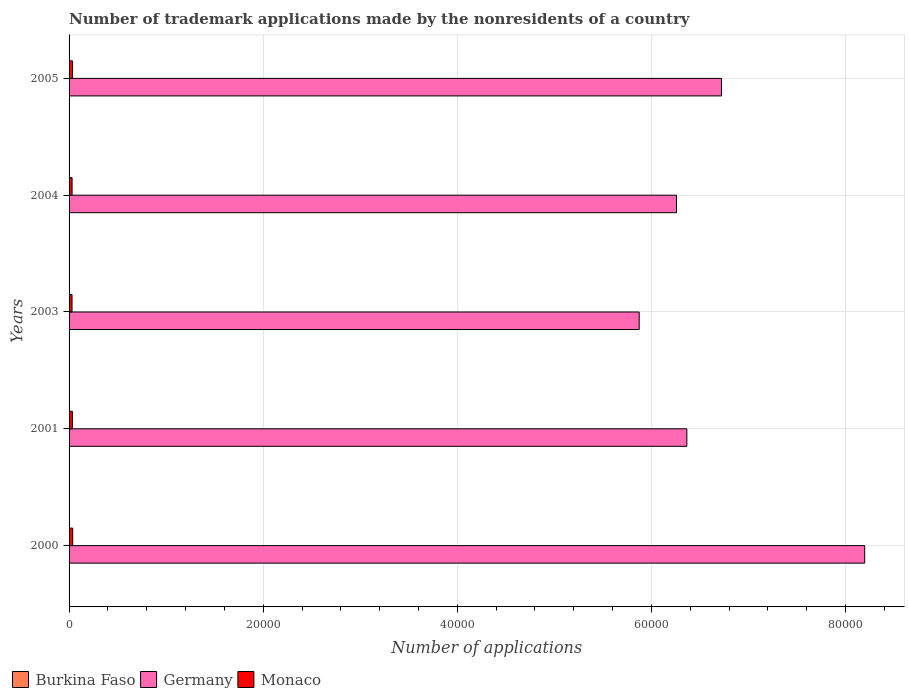How many groups of bars are there?
Your answer should be compact. 5. How many bars are there on the 2nd tick from the bottom?
Ensure brevity in your answer.  3. In how many cases, is the number of bars for a given year not equal to the number of legend labels?
Give a very brief answer. 0. Across all years, what is the maximum number of trademark applications made by the nonresidents in Germany?
Your answer should be compact. 8.20e+04. Across all years, what is the minimum number of trademark applications made by the nonresidents in Monaco?
Your response must be concise. 305. In which year was the number of trademark applications made by the nonresidents in Germany minimum?
Make the answer very short. 2003. What is the total number of trademark applications made by the nonresidents in Germany in the graph?
Your response must be concise. 3.34e+05. What is the difference between the number of trademark applications made by the nonresidents in Germany in 2000 and that in 2003?
Offer a very short reply. 2.32e+04. What is the difference between the number of trademark applications made by the nonresidents in Germany in 2005 and the number of trademark applications made by the nonresidents in Monaco in 2003?
Offer a very short reply. 6.69e+04. What is the average number of trademark applications made by the nonresidents in Germany per year?
Provide a short and direct response. 6.68e+04. In the year 2004, what is the difference between the number of trademark applications made by the nonresidents in Burkina Faso and number of trademark applications made by the nonresidents in Germany?
Give a very brief answer. -6.25e+04. In how many years, is the number of trademark applications made by the nonresidents in Germany greater than 56000 ?
Provide a succinct answer. 5. What is the ratio of the number of trademark applications made by the nonresidents in Germany in 2001 to that in 2005?
Provide a succinct answer. 0.95. Is the number of trademark applications made by the nonresidents in Germany in 2000 less than that in 2005?
Your answer should be compact. No. What is the difference between the highest and the lowest number of trademark applications made by the nonresidents in Germany?
Keep it short and to the point. 2.32e+04. In how many years, is the number of trademark applications made by the nonresidents in Germany greater than the average number of trademark applications made by the nonresidents in Germany taken over all years?
Your answer should be very brief. 2. Is the sum of the number of trademark applications made by the nonresidents in Monaco in 2001 and 2003 greater than the maximum number of trademark applications made by the nonresidents in Burkina Faso across all years?
Offer a very short reply. Yes. What does the 1st bar from the bottom in 2004 represents?
Offer a terse response. Burkina Faso. Is it the case that in every year, the sum of the number of trademark applications made by the nonresidents in Germany and number of trademark applications made by the nonresidents in Monaco is greater than the number of trademark applications made by the nonresidents in Burkina Faso?
Your answer should be compact. Yes. Are all the bars in the graph horizontal?
Your answer should be very brief. Yes. What is the difference between two consecutive major ticks on the X-axis?
Offer a terse response. 2.00e+04. Are the values on the major ticks of X-axis written in scientific E-notation?
Offer a very short reply. No. Does the graph contain grids?
Ensure brevity in your answer.  Yes. Where does the legend appear in the graph?
Offer a terse response. Bottom left. How many legend labels are there?
Ensure brevity in your answer.  3. What is the title of the graph?
Offer a very short reply. Number of trademark applications made by the nonresidents of a country. What is the label or title of the X-axis?
Provide a short and direct response. Number of applications. What is the Number of applications of Germany in 2000?
Keep it short and to the point. 8.20e+04. What is the Number of applications in Monaco in 2000?
Your answer should be very brief. 374. What is the Number of applications in Germany in 2001?
Keep it short and to the point. 6.36e+04. What is the Number of applications in Monaco in 2001?
Your answer should be compact. 341. What is the Number of applications of Burkina Faso in 2003?
Give a very brief answer. 35. What is the Number of applications of Germany in 2003?
Provide a succinct answer. 5.87e+04. What is the Number of applications in Monaco in 2003?
Ensure brevity in your answer.  305. What is the Number of applications of Burkina Faso in 2004?
Make the answer very short. 42. What is the Number of applications in Germany in 2004?
Give a very brief answer. 6.26e+04. What is the Number of applications in Monaco in 2004?
Give a very brief answer. 310. What is the Number of applications in Germany in 2005?
Provide a succinct answer. 6.72e+04. What is the Number of applications of Monaco in 2005?
Your answer should be compact. 359. Across all years, what is the maximum Number of applications of Burkina Faso?
Your response must be concise. 42. Across all years, what is the maximum Number of applications in Germany?
Keep it short and to the point. 8.20e+04. Across all years, what is the maximum Number of applications of Monaco?
Provide a succinct answer. 374. Across all years, what is the minimum Number of applications of Burkina Faso?
Make the answer very short. 5. Across all years, what is the minimum Number of applications in Germany?
Provide a short and direct response. 5.87e+04. Across all years, what is the minimum Number of applications in Monaco?
Provide a short and direct response. 305. What is the total Number of applications of Burkina Faso in the graph?
Your response must be concise. 127. What is the total Number of applications of Germany in the graph?
Keep it short and to the point. 3.34e+05. What is the total Number of applications in Monaco in the graph?
Provide a short and direct response. 1689. What is the difference between the Number of applications in Germany in 2000 and that in 2001?
Provide a succinct answer. 1.83e+04. What is the difference between the Number of applications of Monaco in 2000 and that in 2001?
Your answer should be compact. 33. What is the difference between the Number of applications in Germany in 2000 and that in 2003?
Provide a short and direct response. 2.32e+04. What is the difference between the Number of applications in Burkina Faso in 2000 and that in 2004?
Provide a succinct answer. -37. What is the difference between the Number of applications in Germany in 2000 and that in 2004?
Your answer should be very brief. 1.94e+04. What is the difference between the Number of applications of Burkina Faso in 2000 and that in 2005?
Provide a succinct answer. -25. What is the difference between the Number of applications in Germany in 2000 and that in 2005?
Offer a terse response. 1.48e+04. What is the difference between the Number of applications of Burkina Faso in 2001 and that in 2003?
Offer a terse response. -20. What is the difference between the Number of applications in Germany in 2001 and that in 2003?
Your response must be concise. 4910. What is the difference between the Number of applications of Burkina Faso in 2001 and that in 2004?
Provide a short and direct response. -27. What is the difference between the Number of applications in Germany in 2001 and that in 2004?
Provide a succinct answer. 1065. What is the difference between the Number of applications in Monaco in 2001 and that in 2004?
Provide a short and direct response. 31. What is the difference between the Number of applications in Germany in 2001 and that in 2005?
Your response must be concise. -3567. What is the difference between the Number of applications of Monaco in 2001 and that in 2005?
Offer a very short reply. -18. What is the difference between the Number of applications of Burkina Faso in 2003 and that in 2004?
Keep it short and to the point. -7. What is the difference between the Number of applications in Germany in 2003 and that in 2004?
Offer a terse response. -3845. What is the difference between the Number of applications in Monaco in 2003 and that in 2004?
Provide a short and direct response. -5. What is the difference between the Number of applications in Germany in 2003 and that in 2005?
Ensure brevity in your answer.  -8477. What is the difference between the Number of applications in Monaco in 2003 and that in 2005?
Your answer should be very brief. -54. What is the difference between the Number of applications of Burkina Faso in 2004 and that in 2005?
Ensure brevity in your answer.  12. What is the difference between the Number of applications of Germany in 2004 and that in 2005?
Provide a succinct answer. -4632. What is the difference between the Number of applications of Monaco in 2004 and that in 2005?
Your answer should be compact. -49. What is the difference between the Number of applications of Burkina Faso in 2000 and the Number of applications of Germany in 2001?
Make the answer very short. -6.36e+04. What is the difference between the Number of applications in Burkina Faso in 2000 and the Number of applications in Monaco in 2001?
Keep it short and to the point. -336. What is the difference between the Number of applications in Germany in 2000 and the Number of applications in Monaco in 2001?
Provide a short and direct response. 8.16e+04. What is the difference between the Number of applications of Burkina Faso in 2000 and the Number of applications of Germany in 2003?
Provide a succinct answer. -5.87e+04. What is the difference between the Number of applications in Burkina Faso in 2000 and the Number of applications in Monaco in 2003?
Your answer should be very brief. -300. What is the difference between the Number of applications of Germany in 2000 and the Number of applications of Monaco in 2003?
Give a very brief answer. 8.17e+04. What is the difference between the Number of applications in Burkina Faso in 2000 and the Number of applications in Germany in 2004?
Make the answer very short. -6.26e+04. What is the difference between the Number of applications of Burkina Faso in 2000 and the Number of applications of Monaco in 2004?
Keep it short and to the point. -305. What is the difference between the Number of applications in Germany in 2000 and the Number of applications in Monaco in 2004?
Offer a terse response. 8.17e+04. What is the difference between the Number of applications of Burkina Faso in 2000 and the Number of applications of Germany in 2005?
Ensure brevity in your answer.  -6.72e+04. What is the difference between the Number of applications in Burkina Faso in 2000 and the Number of applications in Monaco in 2005?
Provide a short and direct response. -354. What is the difference between the Number of applications of Germany in 2000 and the Number of applications of Monaco in 2005?
Provide a short and direct response. 8.16e+04. What is the difference between the Number of applications of Burkina Faso in 2001 and the Number of applications of Germany in 2003?
Offer a very short reply. -5.87e+04. What is the difference between the Number of applications of Burkina Faso in 2001 and the Number of applications of Monaco in 2003?
Provide a short and direct response. -290. What is the difference between the Number of applications of Germany in 2001 and the Number of applications of Monaco in 2003?
Your response must be concise. 6.33e+04. What is the difference between the Number of applications of Burkina Faso in 2001 and the Number of applications of Germany in 2004?
Keep it short and to the point. -6.26e+04. What is the difference between the Number of applications of Burkina Faso in 2001 and the Number of applications of Monaco in 2004?
Your response must be concise. -295. What is the difference between the Number of applications in Germany in 2001 and the Number of applications in Monaco in 2004?
Offer a terse response. 6.33e+04. What is the difference between the Number of applications in Burkina Faso in 2001 and the Number of applications in Germany in 2005?
Provide a succinct answer. -6.72e+04. What is the difference between the Number of applications of Burkina Faso in 2001 and the Number of applications of Monaco in 2005?
Offer a very short reply. -344. What is the difference between the Number of applications of Germany in 2001 and the Number of applications of Monaco in 2005?
Offer a very short reply. 6.33e+04. What is the difference between the Number of applications of Burkina Faso in 2003 and the Number of applications of Germany in 2004?
Give a very brief answer. -6.25e+04. What is the difference between the Number of applications in Burkina Faso in 2003 and the Number of applications in Monaco in 2004?
Your response must be concise. -275. What is the difference between the Number of applications in Germany in 2003 and the Number of applications in Monaco in 2004?
Ensure brevity in your answer.  5.84e+04. What is the difference between the Number of applications of Burkina Faso in 2003 and the Number of applications of Germany in 2005?
Your response must be concise. -6.72e+04. What is the difference between the Number of applications in Burkina Faso in 2003 and the Number of applications in Monaco in 2005?
Give a very brief answer. -324. What is the difference between the Number of applications in Germany in 2003 and the Number of applications in Monaco in 2005?
Provide a short and direct response. 5.84e+04. What is the difference between the Number of applications of Burkina Faso in 2004 and the Number of applications of Germany in 2005?
Your response must be concise. -6.72e+04. What is the difference between the Number of applications of Burkina Faso in 2004 and the Number of applications of Monaco in 2005?
Your answer should be compact. -317. What is the difference between the Number of applications in Germany in 2004 and the Number of applications in Monaco in 2005?
Your response must be concise. 6.22e+04. What is the average Number of applications in Burkina Faso per year?
Offer a terse response. 25.4. What is the average Number of applications of Germany per year?
Your response must be concise. 6.68e+04. What is the average Number of applications in Monaco per year?
Provide a succinct answer. 337.8. In the year 2000, what is the difference between the Number of applications of Burkina Faso and Number of applications of Germany?
Ensure brevity in your answer.  -8.20e+04. In the year 2000, what is the difference between the Number of applications of Burkina Faso and Number of applications of Monaco?
Provide a succinct answer. -369. In the year 2000, what is the difference between the Number of applications of Germany and Number of applications of Monaco?
Offer a terse response. 8.16e+04. In the year 2001, what is the difference between the Number of applications in Burkina Faso and Number of applications in Germany?
Ensure brevity in your answer.  -6.36e+04. In the year 2001, what is the difference between the Number of applications in Burkina Faso and Number of applications in Monaco?
Make the answer very short. -326. In the year 2001, what is the difference between the Number of applications of Germany and Number of applications of Monaco?
Your answer should be very brief. 6.33e+04. In the year 2003, what is the difference between the Number of applications of Burkina Faso and Number of applications of Germany?
Offer a terse response. -5.87e+04. In the year 2003, what is the difference between the Number of applications of Burkina Faso and Number of applications of Monaco?
Make the answer very short. -270. In the year 2003, what is the difference between the Number of applications in Germany and Number of applications in Monaco?
Ensure brevity in your answer.  5.84e+04. In the year 2004, what is the difference between the Number of applications in Burkina Faso and Number of applications in Germany?
Give a very brief answer. -6.25e+04. In the year 2004, what is the difference between the Number of applications in Burkina Faso and Number of applications in Monaco?
Provide a succinct answer. -268. In the year 2004, what is the difference between the Number of applications in Germany and Number of applications in Monaco?
Your answer should be compact. 6.23e+04. In the year 2005, what is the difference between the Number of applications in Burkina Faso and Number of applications in Germany?
Ensure brevity in your answer.  -6.72e+04. In the year 2005, what is the difference between the Number of applications in Burkina Faso and Number of applications in Monaco?
Offer a terse response. -329. In the year 2005, what is the difference between the Number of applications in Germany and Number of applications in Monaco?
Provide a short and direct response. 6.69e+04. What is the ratio of the Number of applications of Germany in 2000 to that in 2001?
Offer a very short reply. 1.29. What is the ratio of the Number of applications in Monaco in 2000 to that in 2001?
Keep it short and to the point. 1.1. What is the ratio of the Number of applications in Burkina Faso in 2000 to that in 2003?
Ensure brevity in your answer.  0.14. What is the ratio of the Number of applications of Germany in 2000 to that in 2003?
Ensure brevity in your answer.  1.4. What is the ratio of the Number of applications in Monaco in 2000 to that in 2003?
Ensure brevity in your answer.  1.23. What is the ratio of the Number of applications of Burkina Faso in 2000 to that in 2004?
Provide a short and direct response. 0.12. What is the ratio of the Number of applications of Germany in 2000 to that in 2004?
Keep it short and to the point. 1.31. What is the ratio of the Number of applications of Monaco in 2000 to that in 2004?
Ensure brevity in your answer.  1.21. What is the ratio of the Number of applications of Burkina Faso in 2000 to that in 2005?
Keep it short and to the point. 0.17. What is the ratio of the Number of applications of Germany in 2000 to that in 2005?
Your response must be concise. 1.22. What is the ratio of the Number of applications of Monaco in 2000 to that in 2005?
Provide a succinct answer. 1.04. What is the ratio of the Number of applications in Burkina Faso in 2001 to that in 2003?
Provide a succinct answer. 0.43. What is the ratio of the Number of applications in Germany in 2001 to that in 2003?
Provide a short and direct response. 1.08. What is the ratio of the Number of applications in Monaco in 2001 to that in 2003?
Your response must be concise. 1.12. What is the ratio of the Number of applications of Burkina Faso in 2001 to that in 2004?
Ensure brevity in your answer.  0.36. What is the ratio of the Number of applications of Germany in 2001 to that in 2004?
Give a very brief answer. 1.02. What is the ratio of the Number of applications of Monaco in 2001 to that in 2004?
Provide a succinct answer. 1.1. What is the ratio of the Number of applications in Burkina Faso in 2001 to that in 2005?
Offer a very short reply. 0.5. What is the ratio of the Number of applications in Germany in 2001 to that in 2005?
Your response must be concise. 0.95. What is the ratio of the Number of applications of Monaco in 2001 to that in 2005?
Provide a short and direct response. 0.95. What is the ratio of the Number of applications in Burkina Faso in 2003 to that in 2004?
Make the answer very short. 0.83. What is the ratio of the Number of applications of Germany in 2003 to that in 2004?
Offer a terse response. 0.94. What is the ratio of the Number of applications of Monaco in 2003 to that in 2004?
Make the answer very short. 0.98. What is the ratio of the Number of applications of Burkina Faso in 2003 to that in 2005?
Make the answer very short. 1.17. What is the ratio of the Number of applications in Germany in 2003 to that in 2005?
Ensure brevity in your answer.  0.87. What is the ratio of the Number of applications in Monaco in 2003 to that in 2005?
Keep it short and to the point. 0.85. What is the ratio of the Number of applications in Germany in 2004 to that in 2005?
Provide a short and direct response. 0.93. What is the ratio of the Number of applications in Monaco in 2004 to that in 2005?
Offer a terse response. 0.86. What is the difference between the highest and the second highest Number of applications in Burkina Faso?
Your answer should be compact. 7. What is the difference between the highest and the second highest Number of applications of Germany?
Offer a terse response. 1.48e+04. What is the difference between the highest and the lowest Number of applications in Burkina Faso?
Your response must be concise. 37. What is the difference between the highest and the lowest Number of applications in Germany?
Offer a terse response. 2.32e+04. What is the difference between the highest and the lowest Number of applications of Monaco?
Ensure brevity in your answer.  69. 